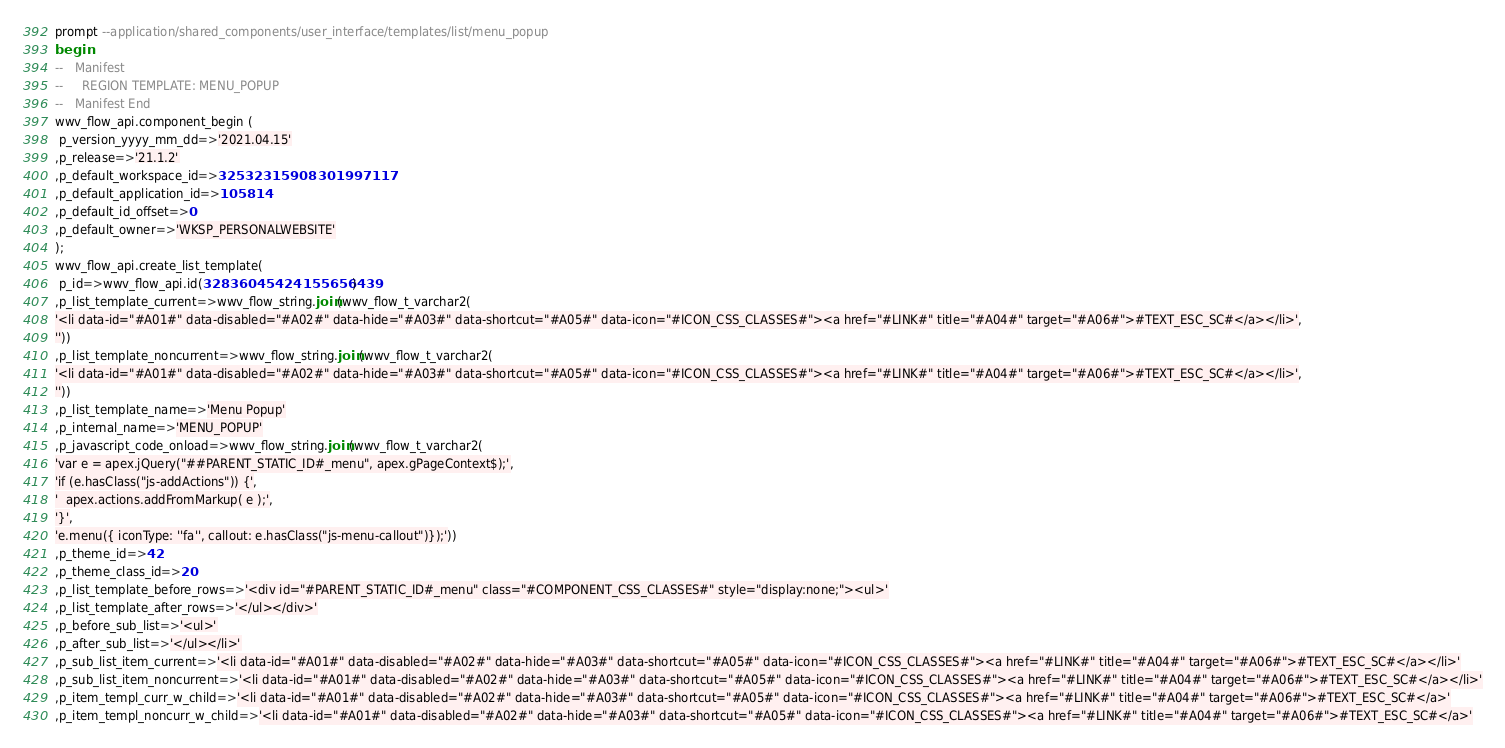<code> <loc_0><loc_0><loc_500><loc_500><_SQL_>prompt --application/shared_components/user_interface/templates/list/menu_popup
begin
--   Manifest
--     REGION TEMPLATE: MENU_POPUP
--   Manifest End
wwv_flow_api.component_begin (
 p_version_yyyy_mm_dd=>'2021.04.15'
,p_release=>'21.1.2'
,p_default_workspace_id=>32532315908301997117
,p_default_application_id=>105814
,p_default_id_offset=>0
,p_default_owner=>'WKSP_PERSONALWEBSITE'
);
wwv_flow_api.create_list_template(
 p_id=>wwv_flow_api.id(32836045424155656439)
,p_list_template_current=>wwv_flow_string.join(wwv_flow_t_varchar2(
'<li data-id="#A01#" data-disabled="#A02#" data-hide="#A03#" data-shortcut="#A05#" data-icon="#ICON_CSS_CLASSES#"><a href="#LINK#" title="#A04#" target="#A06#">#TEXT_ESC_SC#</a></li>',
''))
,p_list_template_noncurrent=>wwv_flow_string.join(wwv_flow_t_varchar2(
'<li data-id="#A01#" data-disabled="#A02#" data-hide="#A03#" data-shortcut="#A05#" data-icon="#ICON_CSS_CLASSES#"><a href="#LINK#" title="#A04#" target="#A06#">#TEXT_ESC_SC#</a></li>',
''))
,p_list_template_name=>'Menu Popup'
,p_internal_name=>'MENU_POPUP'
,p_javascript_code_onload=>wwv_flow_string.join(wwv_flow_t_varchar2(
'var e = apex.jQuery("##PARENT_STATIC_ID#_menu", apex.gPageContext$);',
'if (e.hasClass("js-addActions")) {',
'  apex.actions.addFromMarkup( e );',
'}',
'e.menu({ iconType: ''fa'', callout: e.hasClass("js-menu-callout")});'))
,p_theme_id=>42
,p_theme_class_id=>20
,p_list_template_before_rows=>'<div id="#PARENT_STATIC_ID#_menu" class="#COMPONENT_CSS_CLASSES#" style="display:none;"><ul>'
,p_list_template_after_rows=>'</ul></div>'
,p_before_sub_list=>'<ul>'
,p_after_sub_list=>'</ul></li>'
,p_sub_list_item_current=>'<li data-id="#A01#" data-disabled="#A02#" data-hide="#A03#" data-shortcut="#A05#" data-icon="#ICON_CSS_CLASSES#"><a href="#LINK#" title="#A04#" target="#A06#">#TEXT_ESC_SC#</a></li>'
,p_sub_list_item_noncurrent=>'<li data-id="#A01#" data-disabled="#A02#" data-hide="#A03#" data-shortcut="#A05#" data-icon="#ICON_CSS_CLASSES#"><a href="#LINK#" title="#A04#" target="#A06#">#TEXT_ESC_SC#</a></li>'
,p_item_templ_curr_w_child=>'<li data-id="#A01#" data-disabled="#A02#" data-hide="#A03#" data-shortcut="#A05#" data-icon="#ICON_CSS_CLASSES#"><a href="#LINK#" title="#A04#" target="#A06#">#TEXT_ESC_SC#</a>'
,p_item_templ_noncurr_w_child=>'<li data-id="#A01#" data-disabled="#A02#" data-hide="#A03#" data-shortcut="#A05#" data-icon="#ICON_CSS_CLASSES#"><a href="#LINK#" title="#A04#" target="#A06#">#TEXT_ESC_SC#</a>'</code> 